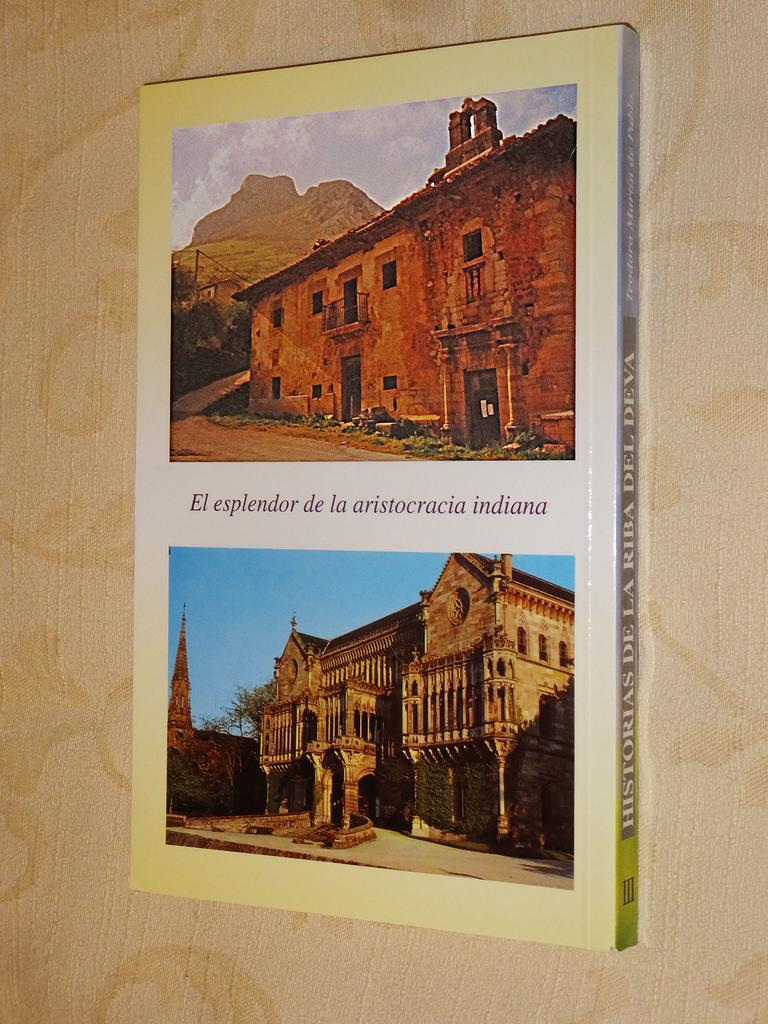What is present on the wall in the image? There is a poster in the image. What is depicted on the poster? The poster contains images of buildings and hills. Who is the creator of the dinner depicted in the image? There is no dinner depicted in the image; it features a poster with images of buildings and hills. 